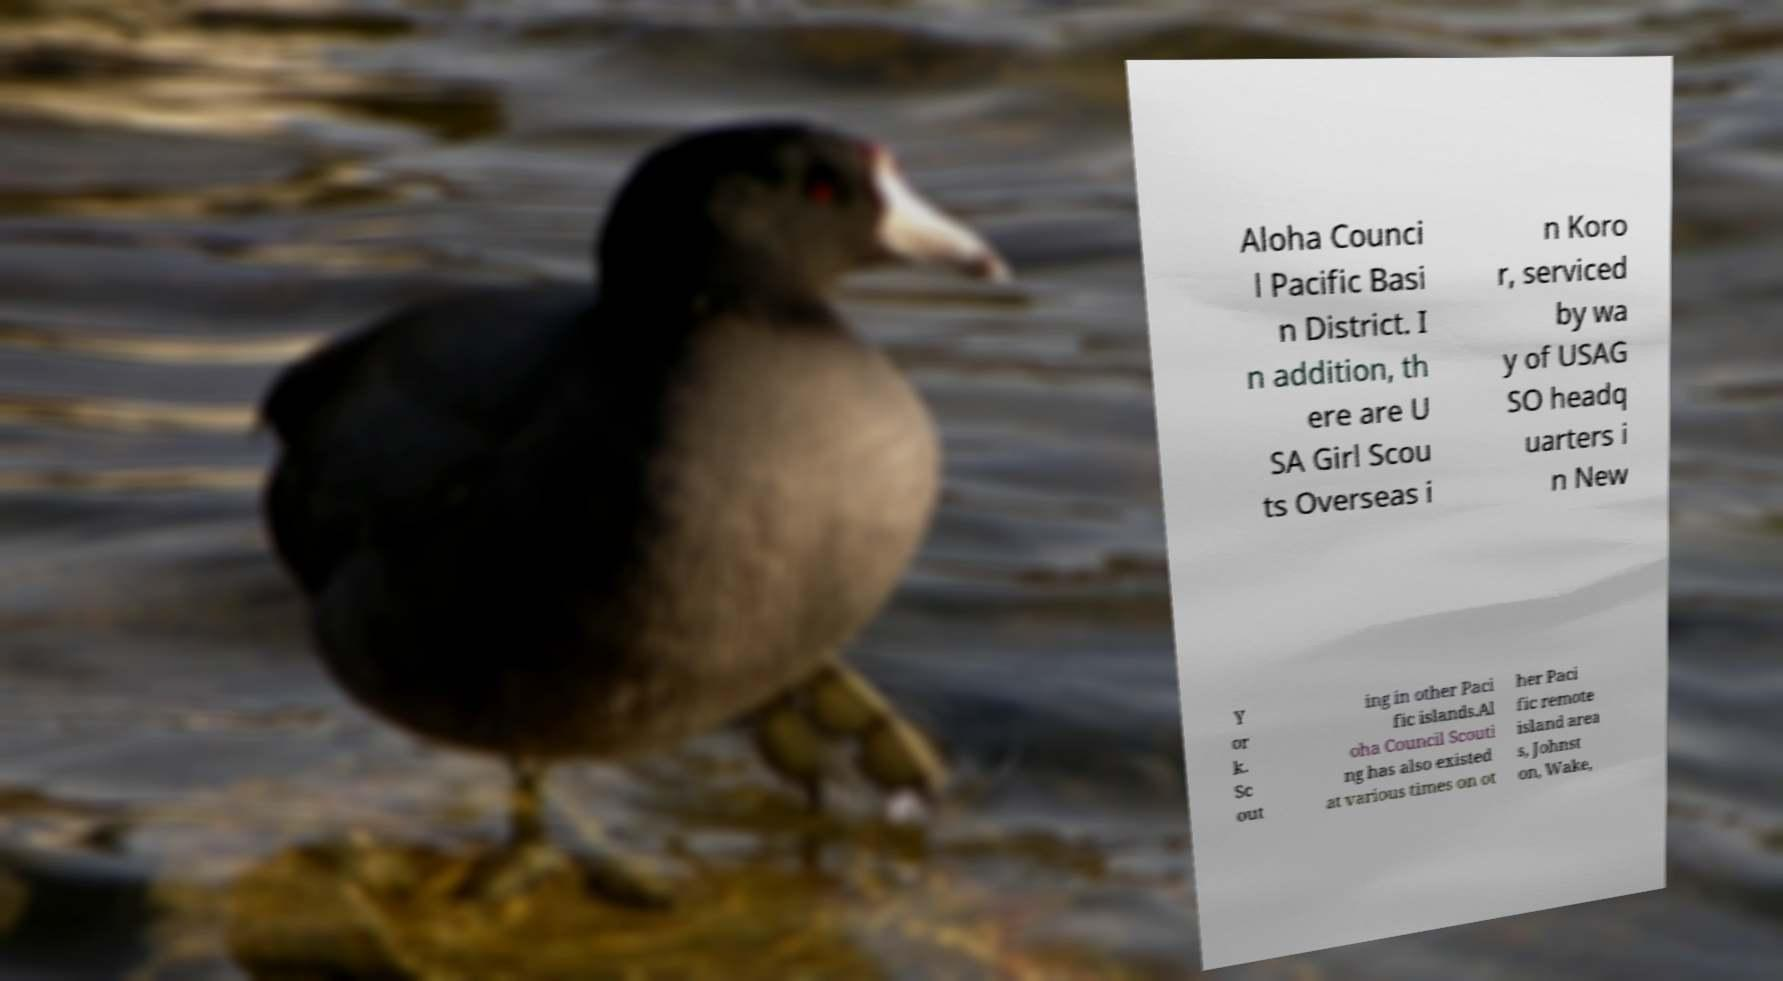For documentation purposes, I need the text within this image transcribed. Could you provide that? Aloha Counci l Pacific Basi n District. I n addition, th ere are U SA Girl Scou ts Overseas i n Koro r, serviced by wa y of USAG SO headq uarters i n New Y or k. Sc out ing in other Paci fic islands.Al oha Council Scouti ng has also existed at various times on ot her Paci fic remote island area s, Johnst on, Wake, 